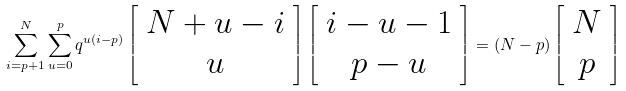<formula> <loc_0><loc_0><loc_500><loc_500>\sum _ { i = p + 1 } ^ { N } \sum _ { u = 0 } ^ { p } q ^ { u ( i - p ) } \left [ \begin{array} { c } N + u - i \\ u \end{array} \right ] \left [ \begin{array} { c } i - u - 1 \\ p - u \end{array} \right ] = ( N - p ) \left [ \begin{array} { c } N \\ p \end{array} \right ]</formula> 